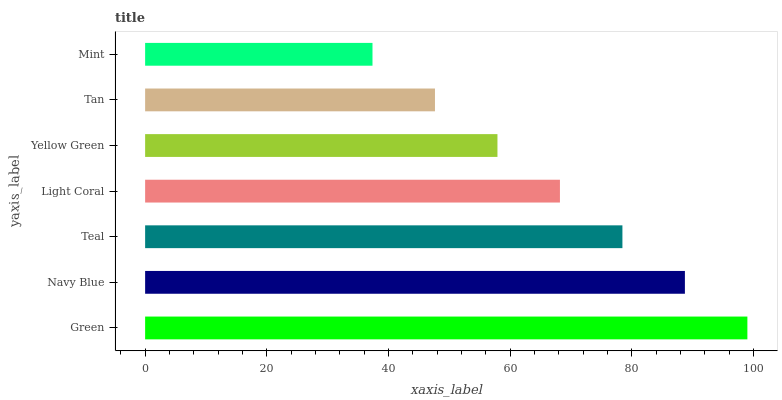Is Mint the minimum?
Answer yes or no. Yes. Is Green the maximum?
Answer yes or no. Yes. Is Navy Blue the minimum?
Answer yes or no. No. Is Navy Blue the maximum?
Answer yes or no. No. Is Green greater than Navy Blue?
Answer yes or no. Yes. Is Navy Blue less than Green?
Answer yes or no. Yes. Is Navy Blue greater than Green?
Answer yes or no. No. Is Green less than Navy Blue?
Answer yes or no. No. Is Light Coral the high median?
Answer yes or no. Yes. Is Light Coral the low median?
Answer yes or no. Yes. Is Green the high median?
Answer yes or no. No. Is Tan the low median?
Answer yes or no. No. 